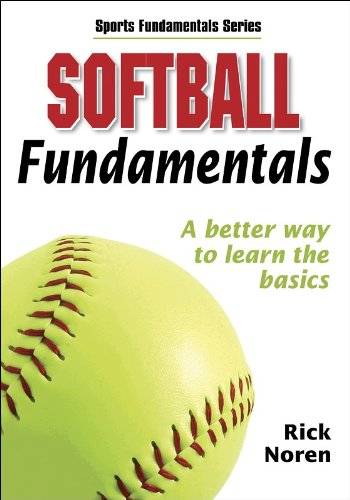What age group is this book targeted towards? The 'Softball Fundamentals' book is targeted primarily towards beginners of all ages, making it suitable for young players and adults who are new to the sport. 